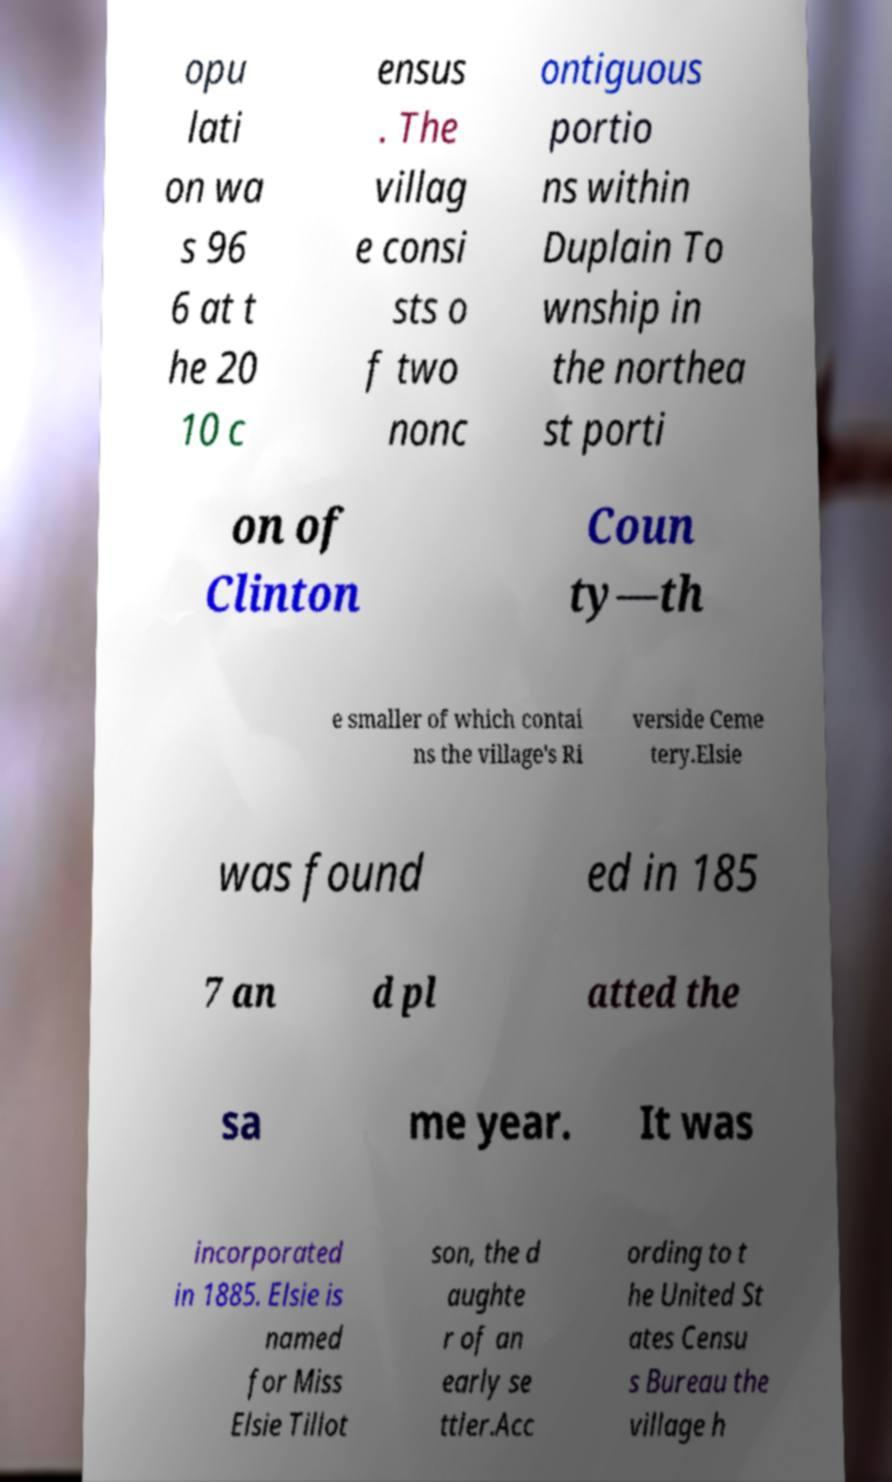Could you extract and type out the text from this image? opu lati on wa s 96 6 at t he 20 10 c ensus . The villag e consi sts o f two nonc ontiguous portio ns within Duplain To wnship in the northea st porti on of Clinton Coun ty—th e smaller of which contai ns the village's Ri verside Ceme tery.Elsie was found ed in 185 7 an d pl atted the sa me year. It was incorporated in 1885. Elsie is named for Miss Elsie Tillot son, the d aughte r of an early se ttler.Acc ording to t he United St ates Censu s Bureau the village h 